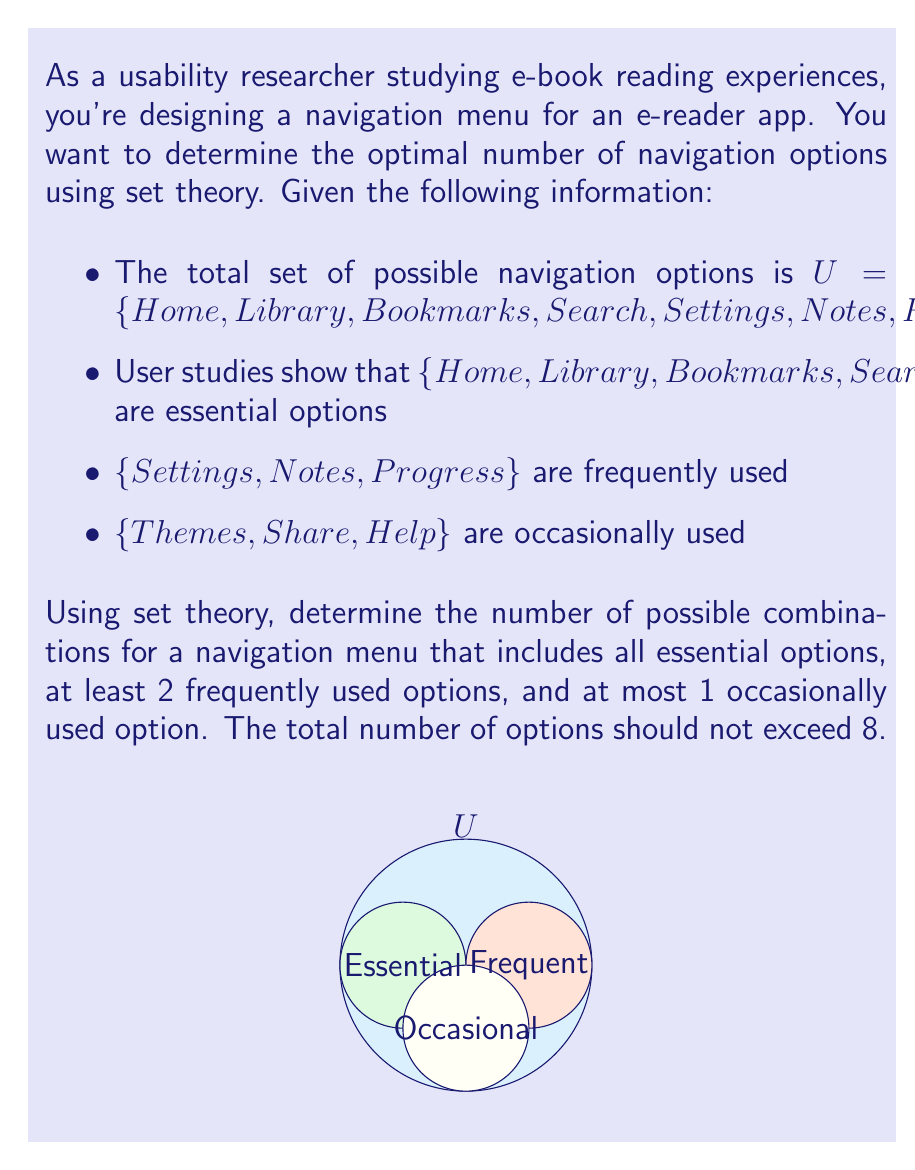Help me with this question. Let's approach this step-by-step using set theory:

1) First, we need to include all essential options. This is non-negotiable:
   $E = \{Home, Library, Bookmarks, Search\}$
   $|E| = 4$

2) For frequently used options:
   $F = \{Settings, Notes, Progress\}$
   We need to choose at least 2 from this set. We can choose either 2 or 3.
   Number of ways to choose 2: $\binom{3}{2} = 3$
   Number of ways to choose 3: $\binom{3}{3} = 1$

3) For occasionally used options:
   $O = \{Themes, Share, Help\}$
   We can choose at most 1 from this set. We can choose either 0 or 1.
   Number of ways to choose 0: $\binom{3}{0} = 1$
   Number of ways to choose 1: $\binom{3}{1} = 3$

4) Now, let's consider the combinations:

   a) Essential (4) + 2 Frequent + 0 Occasional: $3 \cdot 1 = 3$ combinations
   b) Essential (4) + 2 Frequent + 1 Occasional: $3 \cdot 3 = 9$ combinations
   c) Essential (4) + 3 Frequent + 0 Occasional: $1 \cdot 1 = 1$ combination
   d) Essential (4) + 3 Frequent + 1 Occasional: $1 \cdot 3 = 3$ combinations

5) The total number of possible combinations is the sum of all these:
   $3 + 9 + 1 + 3 = 16$

Therefore, there are 16 possible combinations for the navigation menu that satisfy all the given conditions.
Answer: 16 combinations 